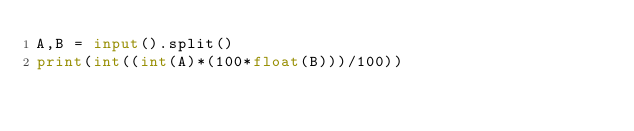<code> <loc_0><loc_0><loc_500><loc_500><_Python_>A,B = input().split()
print(int((int(A)*(100*float(B)))/100))</code> 